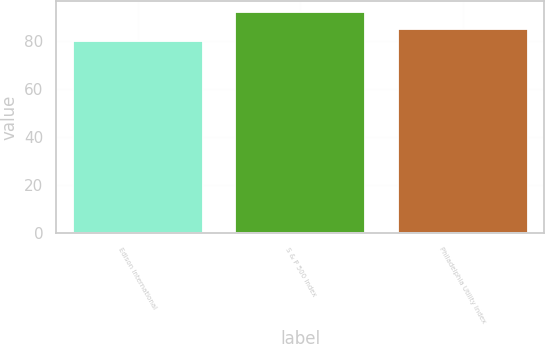Convert chart. <chart><loc_0><loc_0><loc_500><loc_500><bar_chart><fcel>Edison International<fcel>S & P 500 Index<fcel>Philadelphia Utility Index<nl><fcel>80<fcel>92<fcel>85<nl></chart> 